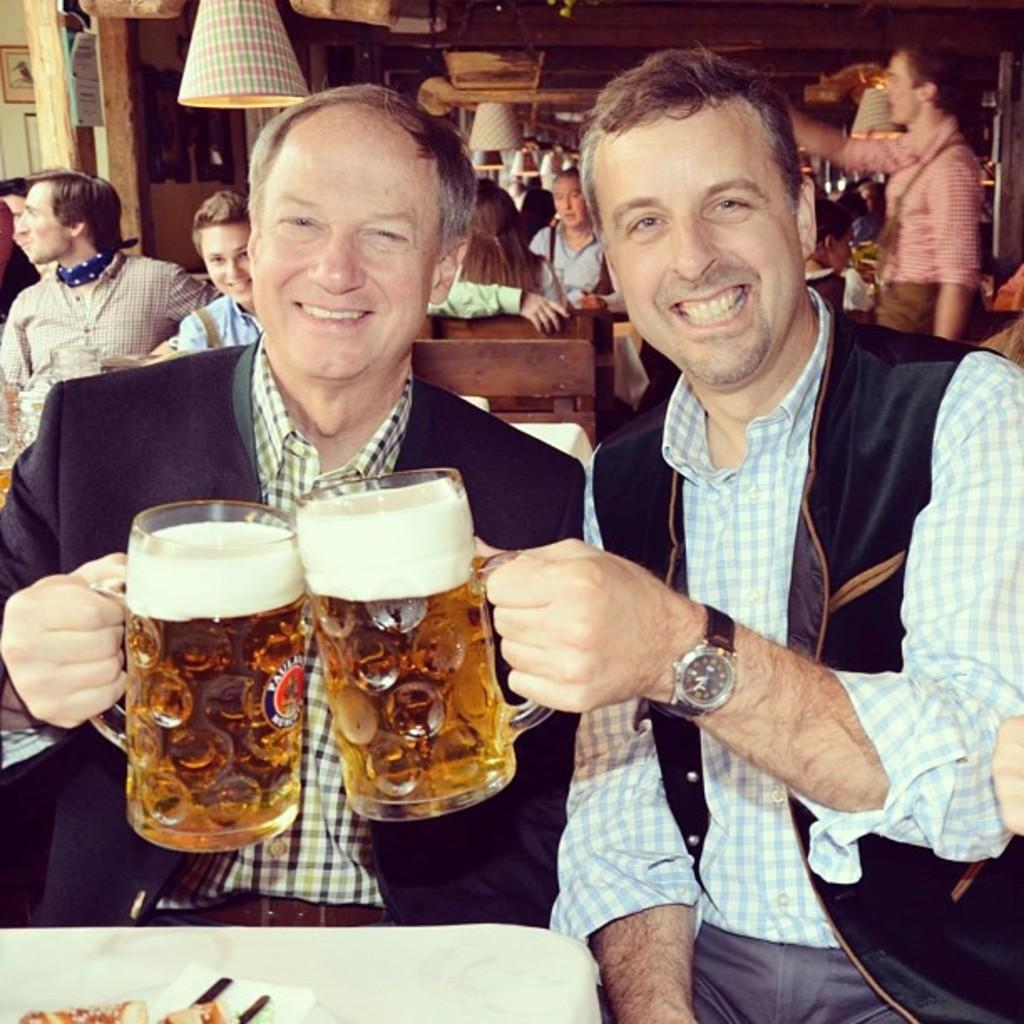How many persons are sitting on chairs in the image? There are two persons sitting on a chair in the image. What are the two sitting persons holding? The two sitting persons are holding a glass with liquid. Are there any other persons sitting on chairs in the image? Yes, there are many other persons sitting on chairs in the image. What is the position of the person standing in the image? There is a person standing in the image. What is the facial expression of the two sitting persons? The two sitting persons are smiling. What type of fish can be seen swimming in the glass held by the two sitting persons? There are no fish present in the image; the two sitting persons are holding a glass with liquid, but it is not specified as fish or any other specific substance. 